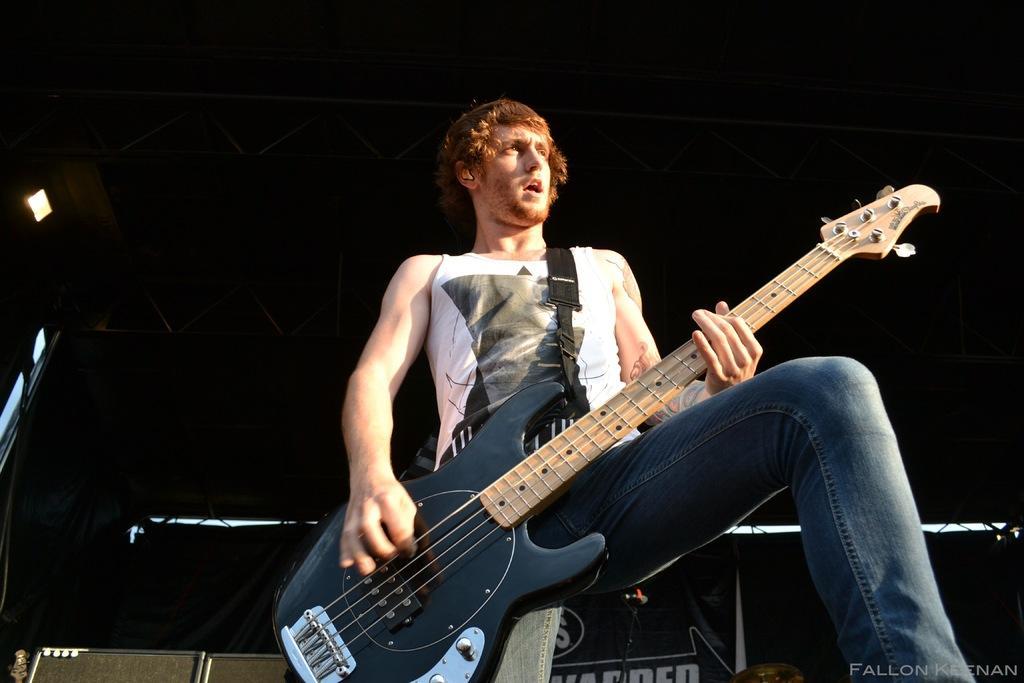Please provide a concise description of this image. In this image we can see a man holding musical instruments in their hands. In the background there are grills and electric lights. 